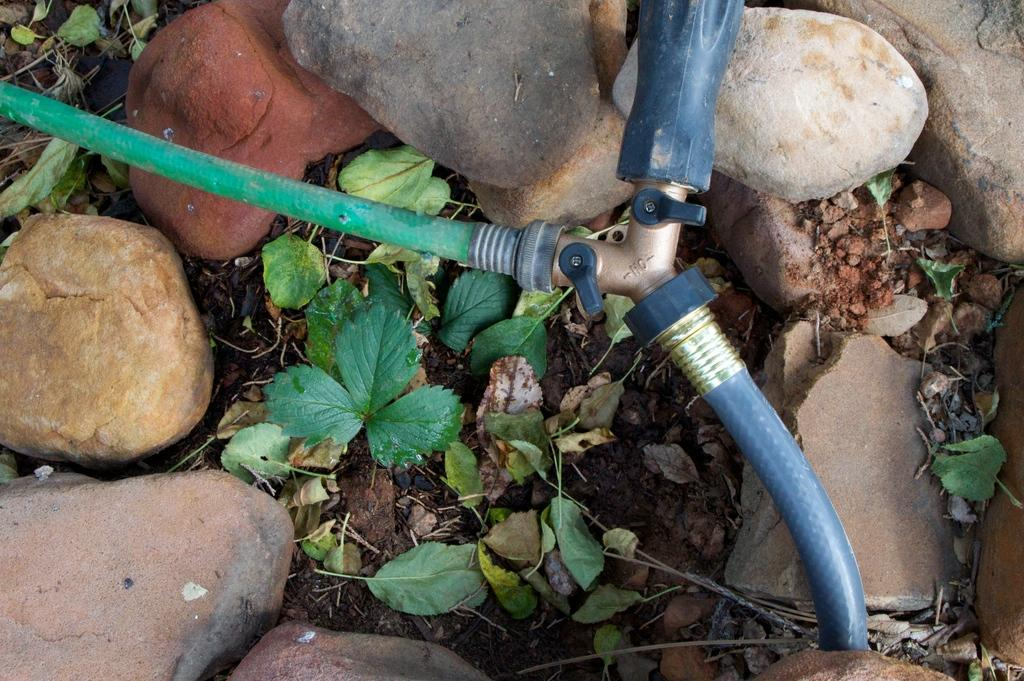What object is the main focus of the image? There is a tap in the image. What colors are the pipes connected to the tap? The pipes connected to the tap are in green and blue colors. What type of surface is visible at the bottom of the image? Soil is visible at the bottom of the image. What type of plant material can be seen in the image? Leaves are present in the image. What type of inorganic material is visible in the image? Stones are visible in the image. Where is the lunchroom located in the image? There is no lunchroom present in the image. What type of meat is being prepared in the image? There is no meat or preparation of food visible in the image. 